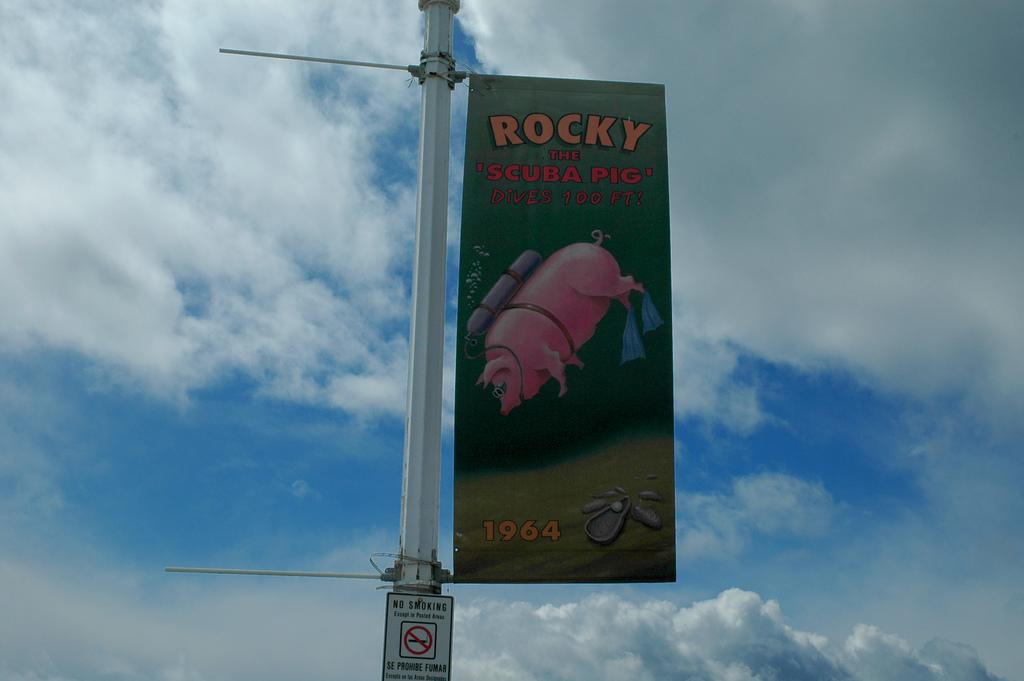Provide a one-sentence caption for the provided image. A sign advertized on a pole that says, Rocky the Scuba Pig Dives 100 FT! 1964. 